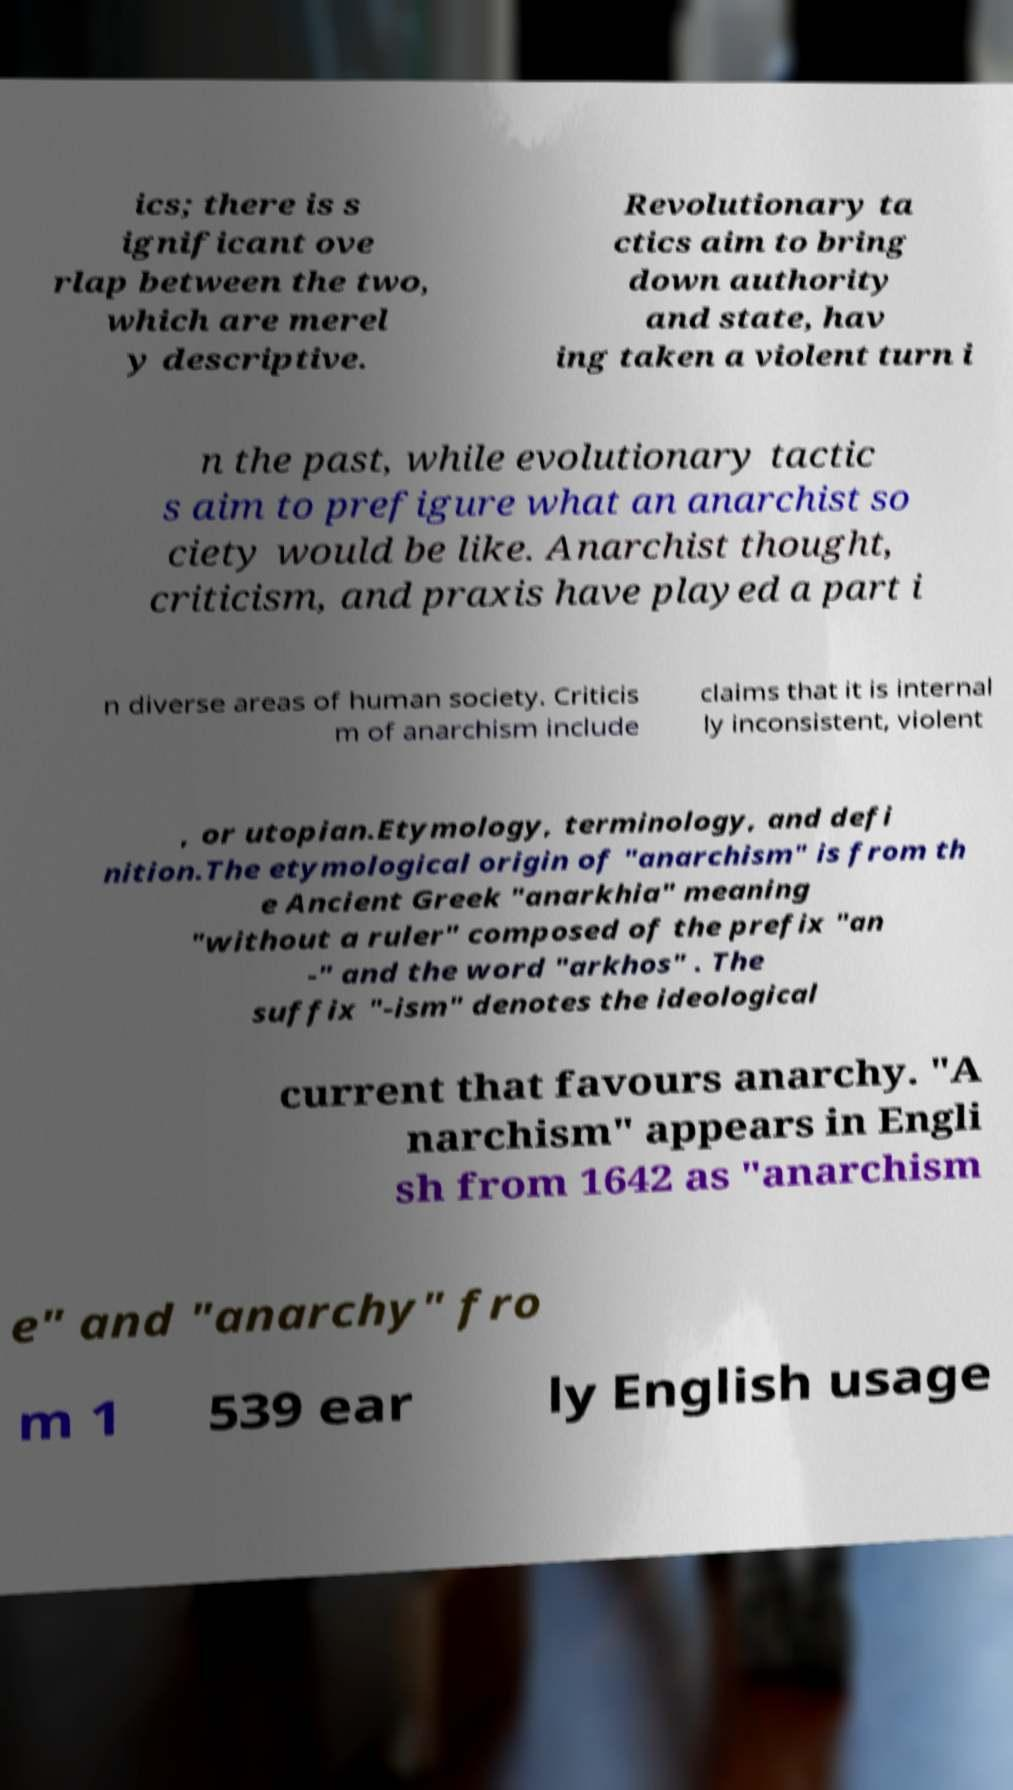What messages or text are displayed in this image? I need them in a readable, typed format. ics; there is s ignificant ove rlap between the two, which are merel y descriptive. Revolutionary ta ctics aim to bring down authority and state, hav ing taken a violent turn i n the past, while evolutionary tactic s aim to prefigure what an anarchist so ciety would be like. Anarchist thought, criticism, and praxis have played a part i n diverse areas of human society. Criticis m of anarchism include claims that it is internal ly inconsistent, violent , or utopian.Etymology, terminology, and defi nition.The etymological origin of "anarchism" is from th e Ancient Greek "anarkhia" meaning "without a ruler" composed of the prefix "an -" and the word "arkhos" . The suffix "-ism" denotes the ideological current that favours anarchy. "A narchism" appears in Engli sh from 1642 as "anarchism e" and "anarchy" fro m 1 539 ear ly English usage 